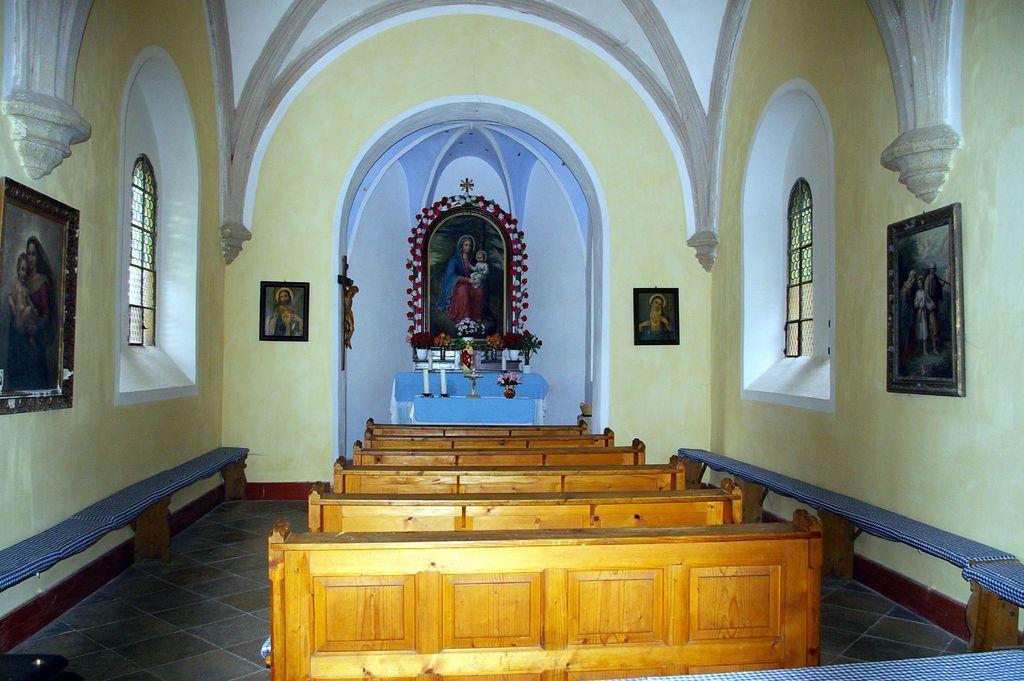Could you give a brief overview of what you see in this image? In this image there are tables, benches. There are photo frames on the wall. There are windows. In the background of the image there are some objects on the stairs. 